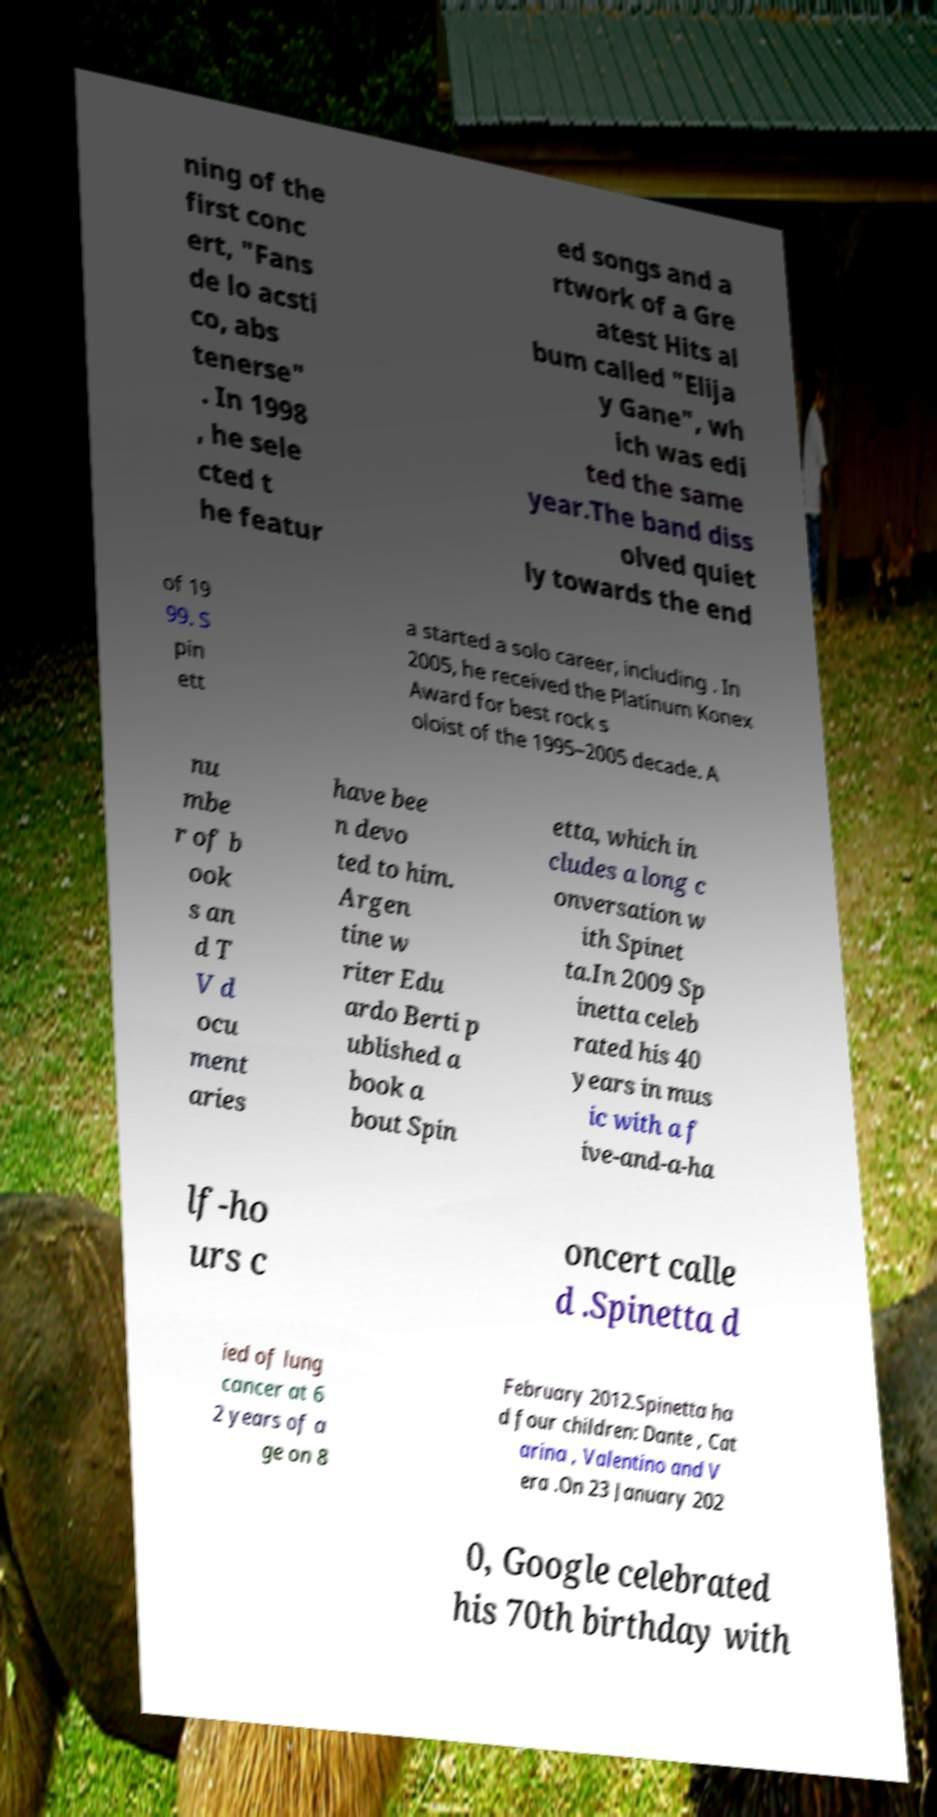I need the written content from this picture converted into text. Can you do that? ning of the first conc ert, "Fans de lo acsti co, abs tenerse" . In 1998 , he sele cted t he featur ed songs and a rtwork of a Gre atest Hits al bum called "Elija y Gane", wh ich was edi ted the same year.The band diss olved quiet ly towards the end of 19 99. S pin ett a started a solo career, including . In 2005, he received the Platinum Konex Award for best rock s oloist of the 1995–2005 decade. A nu mbe r of b ook s an d T V d ocu ment aries have bee n devo ted to him. Argen tine w riter Edu ardo Berti p ublished a book a bout Spin etta, which in cludes a long c onversation w ith Spinet ta.In 2009 Sp inetta celeb rated his 40 years in mus ic with a f ive-and-a-ha lf-ho urs c oncert calle d .Spinetta d ied of lung cancer at 6 2 years of a ge on 8 February 2012.Spinetta ha d four children: Dante , Cat arina , Valentino and V era .On 23 January 202 0, Google celebrated his 70th birthday with 